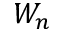<formula> <loc_0><loc_0><loc_500><loc_500>W _ { n }</formula> 